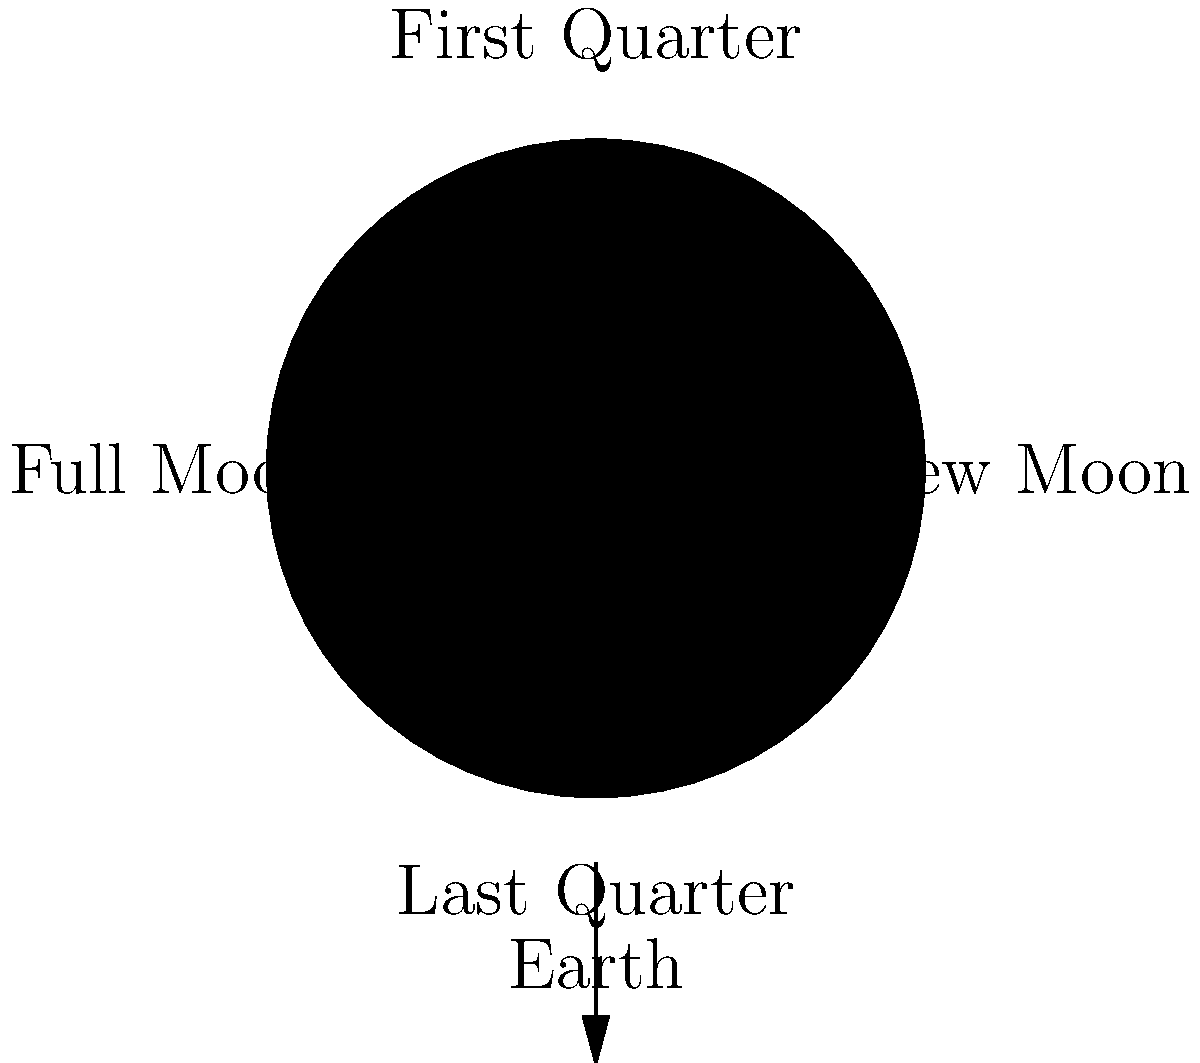As a judo athlete preparing for the Olympics, you often train late into the night. During your evening runs, you notice the moon's changing appearance. Which phase of the moon would provide the most natural light for your outdoor training sessions? To answer this question, let's consider the phases of the moon and their visibility:

1. New Moon: The moon is between the Earth and the Sun, with its dark side facing Earth. It's not visible in the night sky.

2. First Quarter: Half of the moon's illuminated surface is visible from Earth. It appears as a "half moon" and is visible in the early evening.

3. Full Moon: The entire illuminated surface of the moon is visible from Earth. This occurs when the Earth is between the Sun and the moon.

4. Last Quarter: Another "half moon" phase, but visible in the early morning hours.

5. Waxing and Waning Gibbous: These phases occur between the quarter and full moon phases, with more than half but less than the full illuminated surface visible.

The Full Moon provides the most natural light during nighttime because:

a) It reflects the maximum amount of sunlight towards Earth.
b) It's visible throughout the night, from sunset to sunrise.
c) It appears brightest and largest in the sky.

For an athlete training outdoors at night, the Full Moon would offer the most consistent and brightest natural illumination, potentially reducing the need for artificial lighting during late-night training sessions.
Answer: Full Moon 